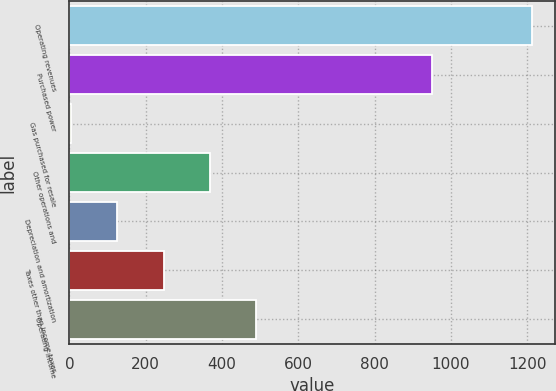Convert chart. <chart><loc_0><loc_0><loc_500><loc_500><bar_chart><fcel>Operating revenues<fcel>Purchased power<fcel>Gas purchased for resale<fcel>Other operations and<fcel>Depreciation and amortization<fcel>Taxes other than income taxes<fcel>Operating income<nl><fcel>1213<fcel>950<fcel>5<fcel>367.4<fcel>125.8<fcel>246.6<fcel>488.2<nl></chart> 